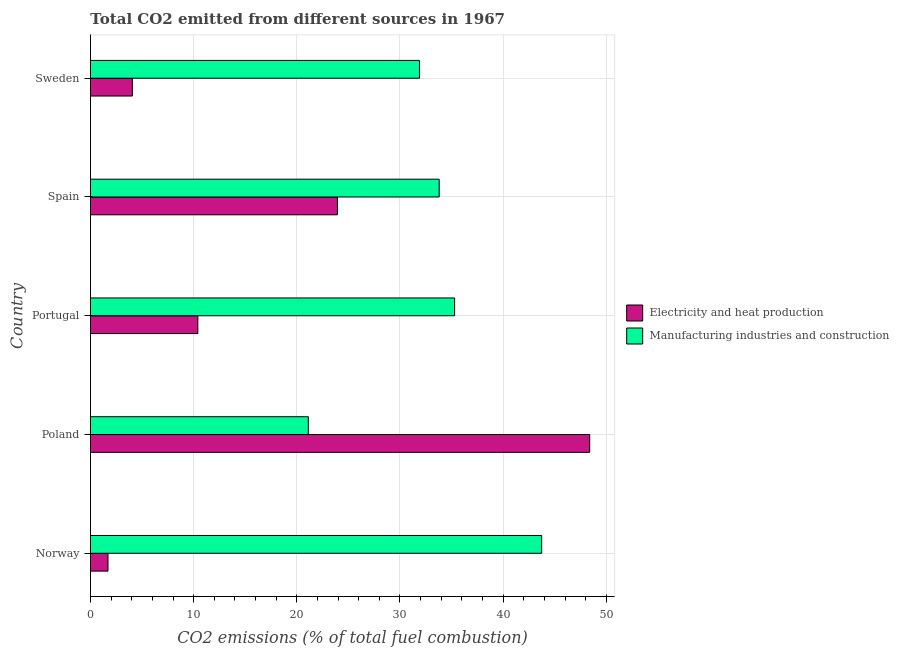How many groups of bars are there?
Your answer should be very brief. 5. How many bars are there on the 3rd tick from the top?
Give a very brief answer. 2. In how many cases, is the number of bars for a given country not equal to the number of legend labels?
Your answer should be very brief. 0. What is the co2 emissions due to manufacturing industries in Norway?
Provide a succinct answer. 43.74. Across all countries, what is the maximum co2 emissions due to electricity and heat production?
Your answer should be very brief. 48.39. Across all countries, what is the minimum co2 emissions due to manufacturing industries?
Provide a succinct answer. 21.12. In which country was the co2 emissions due to electricity and heat production minimum?
Keep it short and to the point. Norway. What is the total co2 emissions due to electricity and heat production in the graph?
Your response must be concise. 88.5. What is the difference between the co2 emissions due to electricity and heat production in Poland and that in Portugal?
Your answer should be very brief. 37.99. What is the difference between the co2 emissions due to manufacturing industries in Poland and the co2 emissions due to electricity and heat production in Spain?
Ensure brevity in your answer.  -2.82. What is the difference between the co2 emissions due to manufacturing industries and co2 emissions due to electricity and heat production in Spain?
Ensure brevity in your answer.  9.87. In how many countries, is the co2 emissions due to electricity and heat production greater than 32 %?
Your answer should be very brief. 1. What is the ratio of the co2 emissions due to manufacturing industries in Norway to that in Portugal?
Keep it short and to the point. 1.24. Is the co2 emissions due to manufacturing industries in Norway less than that in Spain?
Ensure brevity in your answer.  No. Is the difference between the co2 emissions due to manufacturing industries in Spain and Sweden greater than the difference between the co2 emissions due to electricity and heat production in Spain and Sweden?
Keep it short and to the point. No. What is the difference between the highest and the second highest co2 emissions due to manufacturing industries?
Offer a terse response. 8.44. What is the difference between the highest and the lowest co2 emissions due to electricity and heat production?
Your response must be concise. 46.7. In how many countries, is the co2 emissions due to electricity and heat production greater than the average co2 emissions due to electricity and heat production taken over all countries?
Make the answer very short. 2. What does the 2nd bar from the top in Spain represents?
Offer a terse response. Electricity and heat production. What does the 1st bar from the bottom in Norway represents?
Ensure brevity in your answer.  Electricity and heat production. Are all the bars in the graph horizontal?
Provide a short and direct response. Yes. How many countries are there in the graph?
Your response must be concise. 5. Does the graph contain any zero values?
Make the answer very short. No. Where does the legend appear in the graph?
Your answer should be compact. Center right. How are the legend labels stacked?
Offer a very short reply. Vertical. What is the title of the graph?
Make the answer very short. Total CO2 emitted from different sources in 1967. What is the label or title of the X-axis?
Offer a very short reply. CO2 emissions (% of total fuel combustion). What is the CO2 emissions (% of total fuel combustion) in Electricity and heat production in Norway?
Ensure brevity in your answer.  1.7. What is the CO2 emissions (% of total fuel combustion) in Manufacturing industries and construction in Norway?
Your answer should be very brief. 43.74. What is the CO2 emissions (% of total fuel combustion) in Electricity and heat production in Poland?
Your response must be concise. 48.39. What is the CO2 emissions (% of total fuel combustion) of Manufacturing industries and construction in Poland?
Offer a terse response. 21.12. What is the CO2 emissions (% of total fuel combustion) in Electricity and heat production in Portugal?
Your answer should be very brief. 10.41. What is the CO2 emissions (% of total fuel combustion) in Manufacturing industries and construction in Portugal?
Your response must be concise. 35.3. What is the CO2 emissions (% of total fuel combustion) in Electricity and heat production in Spain?
Your answer should be very brief. 23.94. What is the CO2 emissions (% of total fuel combustion) of Manufacturing industries and construction in Spain?
Offer a very short reply. 33.8. What is the CO2 emissions (% of total fuel combustion) of Electricity and heat production in Sweden?
Provide a succinct answer. 4.06. What is the CO2 emissions (% of total fuel combustion) in Manufacturing industries and construction in Sweden?
Your answer should be compact. 31.9. Across all countries, what is the maximum CO2 emissions (% of total fuel combustion) of Electricity and heat production?
Make the answer very short. 48.39. Across all countries, what is the maximum CO2 emissions (% of total fuel combustion) in Manufacturing industries and construction?
Offer a terse response. 43.74. Across all countries, what is the minimum CO2 emissions (% of total fuel combustion) of Electricity and heat production?
Make the answer very short. 1.7. Across all countries, what is the minimum CO2 emissions (% of total fuel combustion) in Manufacturing industries and construction?
Your response must be concise. 21.12. What is the total CO2 emissions (% of total fuel combustion) of Electricity and heat production in the graph?
Ensure brevity in your answer.  88.5. What is the total CO2 emissions (% of total fuel combustion) of Manufacturing industries and construction in the graph?
Your response must be concise. 165.86. What is the difference between the CO2 emissions (% of total fuel combustion) in Electricity and heat production in Norway and that in Poland?
Provide a short and direct response. -46.7. What is the difference between the CO2 emissions (% of total fuel combustion) of Manufacturing industries and construction in Norway and that in Poland?
Provide a succinct answer. 22.62. What is the difference between the CO2 emissions (% of total fuel combustion) of Electricity and heat production in Norway and that in Portugal?
Your answer should be very brief. -8.71. What is the difference between the CO2 emissions (% of total fuel combustion) in Manufacturing industries and construction in Norway and that in Portugal?
Make the answer very short. 8.44. What is the difference between the CO2 emissions (% of total fuel combustion) in Electricity and heat production in Norway and that in Spain?
Ensure brevity in your answer.  -22.24. What is the difference between the CO2 emissions (% of total fuel combustion) of Manufacturing industries and construction in Norway and that in Spain?
Ensure brevity in your answer.  9.93. What is the difference between the CO2 emissions (% of total fuel combustion) of Electricity and heat production in Norway and that in Sweden?
Give a very brief answer. -2.36. What is the difference between the CO2 emissions (% of total fuel combustion) in Manufacturing industries and construction in Norway and that in Sweden?
Make the answer very short. 11.84. What is the difference between the CO2 emissions (% of total fuel combustion) in Electricity and heat production in Poland and that in Portugal?
Offer a terse response. 37.99. What is the difference between the CO2 emissions (% of total fuel combustion) in Manufacturing industries and construction in Poland and that in Portugal?
Offer a terse response. -14.18. What is the difference between the CO2 emissions (% of total fuel combustion) in Electricity and heat production in Poland and that in Spain?
Your response must be concise. 24.46. What is the difference between the CO2 emissions (% of total fuel combustion) in Manufacturing industries and construction in Poland and that in Spain?
Your answer should be compact. -12.69. What is the difference between the CO2 emissions (% of total fuel combustion) of Electricity and heat production in Poland and that in Sweden?
Provide a short and direct response. 44.33. What is the difference between the CO2 emissions (% of total fuel combustion) in Manufacturing industries and construction in Poland and that in Sweden?
Give a very brief answer. -10.78. What is the difference between the CO2 emissions (% of total fuel combustion) of Electricity and heat production in Portugal and that in Spain?
Offer a terse response. -13.53. What is the difference between the CO2 emissions (% of total fuel combustion) in Manufacturing industries and construction in Portugal and that in Spain?
Provide a short and direct response. 1.5. What is the difference between the CO2 emissions (% of total fuel combustion) in Electricity and heat production in Portugal and that in Sweden?
Offer a terse response. 6.35. What is the difference between the CO2 emissions (% of total fuel combustion) in Manufacturing industries and construction in Portugal and that in Sweden?
Your answer should be very brief. 3.4. What is the difference between the CO2 emissions (% of total fuel combustion) in Electricity and heat production in Spain and that in Sweden?
Offer a very short reply. 19.88. What is the difference between the CO2 emissions (% of total fuel combustion) in Manufacturing industries and construction in Spain and that in Sweden?
Your answer should be compact. 1.9. What is the difference between the CO2 emissions (% of total fuel combustion) in Electricity and heat production in Norway and the CO2 emissions (% of total fuel combustion) in Manufacturing industries and construction in Poland?
Offer a very short reply. -19.42. What is the difference between the CO2 emissions (% of total fuel combustion) of Electricity and heat production in Norway and the CO2 emissions (% of total fuel combustion) of Manufacturing industries and construction in Portugal?
Offer a terse response. -33.6. What is the difference between the CO2 emissions (% of total fuel combustion) of Electricity and heat production in Norway and the CO2 emissions (% of total fuel combustion) of Manufacturing industries and construction in Spain?
Give a very brief answer. -32.11. What is the difference between the CO2 emissions (% of total fuel combustion) of Electricity and heat production in Norway and the CO2 emissions (% of total fuel combustion) of Manufacturing industries and construction in Sweden?
Ensure brevity in your answer.  -30.2. What is the difference between the CO2 emissions (% of total fuel combustion) in Electricity and heat production in Poland and the CO2 emissions (% of total fuel combustion) in Manufacturing industries and construction in Portugal?
Offer a terse response. 13.09. What is the difference between the CO2 emissions (% of total fuel combustion) of Electricity and heat production in Poland and the CO2 emissions (% of total fuel combustion) of Manufacturing industries and construction in Spain?
Your answer should be very brief. 14.59. What is the difference between the CO2 emissions (% of total fuel combustion) of Electricity and heat production in Poland and the CO2 emissions (% of total fuel combustion) of Manufacturing industries and construction in Sweden?
Your response must be concise. 16.49. What is the difference between the CO2 emissions (% of total fuel combustion) of Electricity and heat production in Portugal and the CO2 emissions (% of total fuel combustion) of Manufacturing industries and construction in Spain?
Make the answer very short. -23.4. What is the difference between the CO2 emissions (% of total fuel combustion) of Electricity and heat production in Portugal and the CO2 emissions (% of total fuel combustion) of Manufacturing industries and construction in Sweden?
Your response must be concise. -21.49. What is the difference between the CO2 emissions (% of total fuel combustion) in Electricity and heat production in Spain and the CO2 emissions (% of total fuel combustion) in Manufacturing industries and construction in Sweden?
Provide a short and direct response. -7.96. What is the average CO2 emissions (% of total fuel combustion) of Electricity and heat production per country?
Offer a terse response. 17.7. What is the average CO2 emissions (% of total fuel combustion) in Manufacturing industries and construction per country?
Ensure brevity in your answer.  33.17. What is the difference between the CO2 emissions (% of total fuel combustion) in Electricity and heat production and CO2 emissions (% of total fuel combustion) in Manufacturing industries and construction in Norway?
Your response must be concise. -42.04. What is the difference between the CO2 emissions (% of total fuel combustion) in Electricity and heat production and CO2 emissions (% of total fuel combustion) in Manufacturing industries and construction in Poland?
Offer a terse response. 27.28. What is the difference between the CO2 emissions (% of total fuel combustion) in Electricity and heat production and CO2 emissions (% of total fuel combustion) in Manufacturing industries and construction in Portugal?
Provide a succinct answer. -24.89. What is the difference between the CO2 emissions (% of total fuel combustion) of Electricity and heat production and CO2 emissions (% of total fuel combustion) of Manufacturing industries and construction in Spain?
Your answer should be compact. -9.86. What is the difference between the CO2 emissions (% of total fuel combustion) in Electricity and heat production and CO2 emissions (% of total fuel combustion) in Manufacturing industries and construction in Sweden?
Your answer should be compact. -27.84. What is the ratio of the CO2 emissions (% of total fuel combustion) in Electricity and heat production in Norway to that in Poland?
Provide a succinct answer. 0.04. What is the ratio of the CO2 emissions (% of total fuel combustion) in Manufacturing industries and construction in Norway to that in Poland?
Your response must be concise. 2.07. What is the ratio of the CO2 emissions (% of total fuel combustion) of Electricity and heat production in Norway to that in Portugal?
Keep it short and to the point. 0.16. What is the ratio of the CO2 emissions (% of total fuel combustion) of Manufacturing industries and construction in Norway to that in Portugal?
Provide a succinct answer. 1.24. What is the ratio of the CO2 emissions (% of total fuel combustion) of Electricity and heat production in Norway to that in Spain?
Give a very brief answer. 0.07. What is the ratio of the CO2 emissions (% of total fuel combustion) of Manufacturing industries and construction in Norway to that in Spain?
Your response must be concise. 1.29. What is the ratio of the CO2 emissions (% of total fuel combustion) in Electricity and heat production in Norway to that in Sweden?
Offer a very short reply. 0.42. What is the ratio of the CO2 emissions (% of total fuel combustion) of Manufacturing industries and construction in Norway to that in Sweden?
Your answer should be very brief. 1.37. What is the ratio of the CO2 emissions (% of total fuel combustion) of Electricity and heat production in Poland to that in Portugal?
Offer a very short reply. 4.65. What is the ratio of the CO2 emissions (% of total fuel combustion) of Manufacturing industries and construction in Poland to that in Portugal?
Your answer should be compact. 0.6. What is the ratio of the CO2 emissions (% of total fuel combustion) of Electricity and heat production in Poland to that in Spain?
Offer a very short reply. 2.02. What is the ratio of the CO2 emissions (% of total fuel combustion) of Manufacturing industries and construction in Poland to that in Spain?
Offer a terse response. 0.62. What is the ratio of the CO2 emissions (% of total fuel combustion) in Electricity and heat production in Poland to that in Sweden?
Your response must be concise. 11.92. What is the ratio of the CO2 emissions (% of total fuel combustion) in Manufacturing industries and construction in Poland to that in Sweden?
Provide a short and direct response. 0.66. What is the ratio of the CO2 emissions (% of total fuel combustion) of Electricity and heat production in Portugal to that in Spain?
Provide a short and direct response. 0.43. What is the ratio of the CO2 emissions (% of total fuel combustion) in Manufacturing industries and construction in Portugal to that in Spain?
Offer a terse response. 1.04. What is the ratio of the CO2 emissions (% of total fuel combustion) of Electricity and heat production in Portugal to that in Sweden?
Keep it short and to the point. 2.56. What is the ratio of the CO2 emissions (% of total fuel combustion) in Manufacturing industries and construction in Portugal to that in Sweden?
Make the answer very short. 1.11. What is the ratio of the CO2 emissions (% of total fuel combustion) of Electricity and heat production in Spain to that in Sweden?
Your response must be concise. 5.89. What is the ratio of the CO2 emissions (% of total fuel combustion) of Manufacturing industries and construction in Spain to that in Sweden?
Make the answer very short. 1.06. What is the difference between the highest and the second highest CO2 emissions (% of total fuel combustion) in Electricity and heat production?
Your answer should be very brief. 24.46. What is the difference between the highest and the second highest CO2 emissions (% of total fuel combustion) in Manufacturing industries and construction?
Ensure brevity in your answer.  8.44. What is the difference between the highest and the lowest CO2 emissions (% of total fuel combustion) of Electricity and heat production?
Make the answer very short. 46.7. What is the difference between the highest and the lowest CO2 emissions (% of total fuel combustion) of Manufacturing industries and construction?
Make the answer very short. 22.62. 